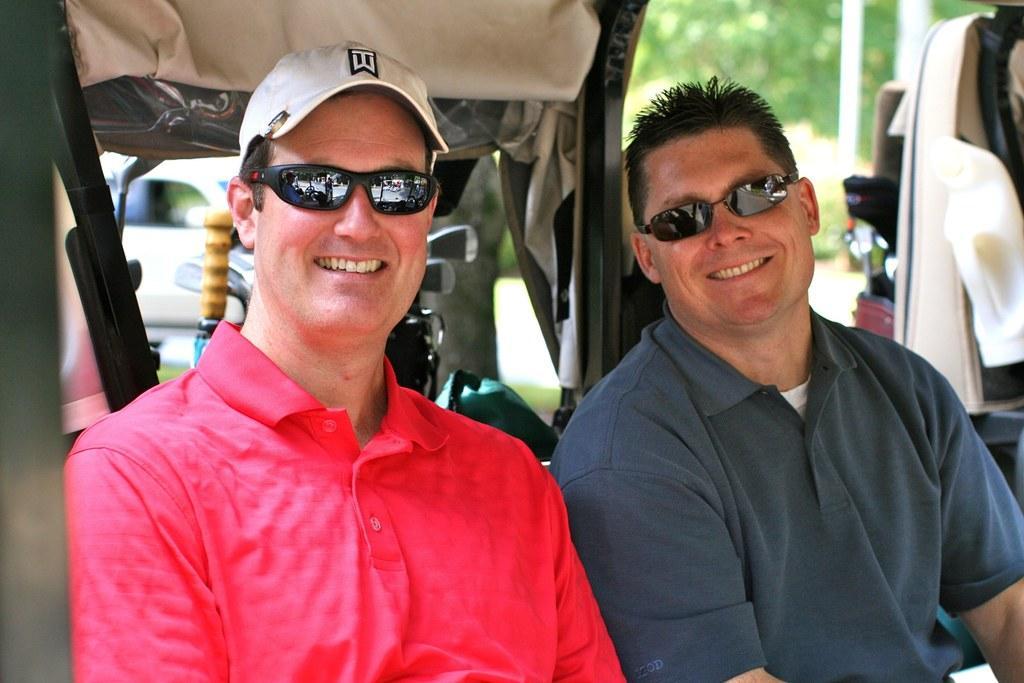How would you summarize this image in a sentence or two? This image is taken outdoors. In the background there is a tree and a car is parked on the road. In the middle of the image two men are sitting in the vehicle and they are with smiling faces. On the right side of the image there is a vehicle parked on the ground. 